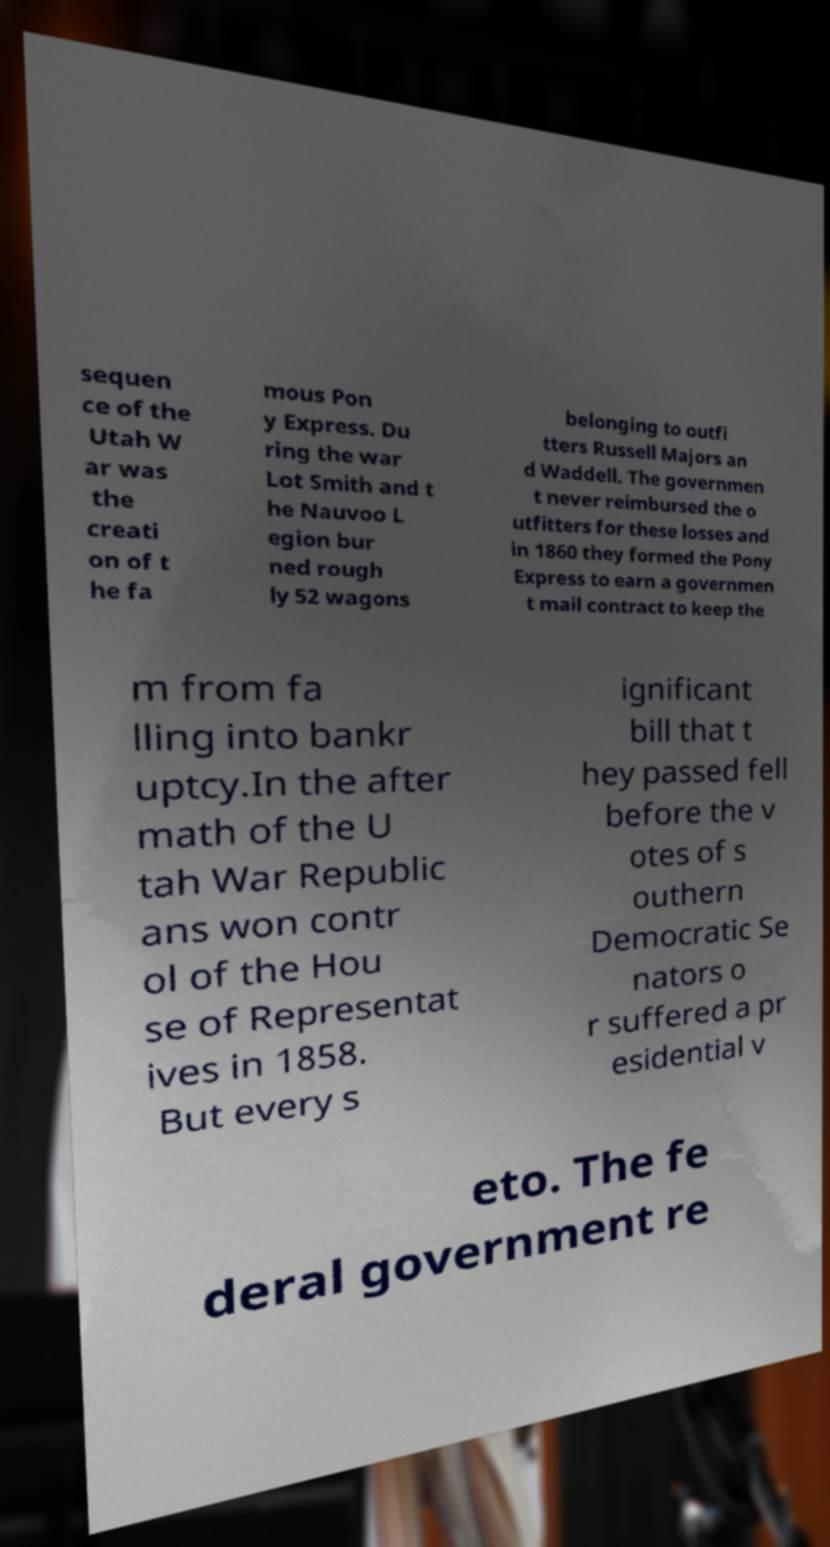There's text embedded in this image that I need extracted. Can you transcribe it verbatim? sequen ce of the Utah W ar was the creati on of t he fa mous Pon y Express. Du ring the war Lot Smith and t he Nauvoo L egion bur ned rough ly 52 wagons belonging to outfi tters Russell Majors an d Waddell. The governmen t never reimbursed the o utfitters for these losses and in 1860 they formed the Pony Express to earn a governmen t mail contract to keep the m from fa lling into bankr uptcy.In the after math of the U tah War Republic ans won contr ol of the Hou se of Representat ives in 1858. But every s ignificant bill that t hey passed fell before the v otes of s outhern Democratic Se nators o r suffered a pr esidential v eto. The fe deral government re 